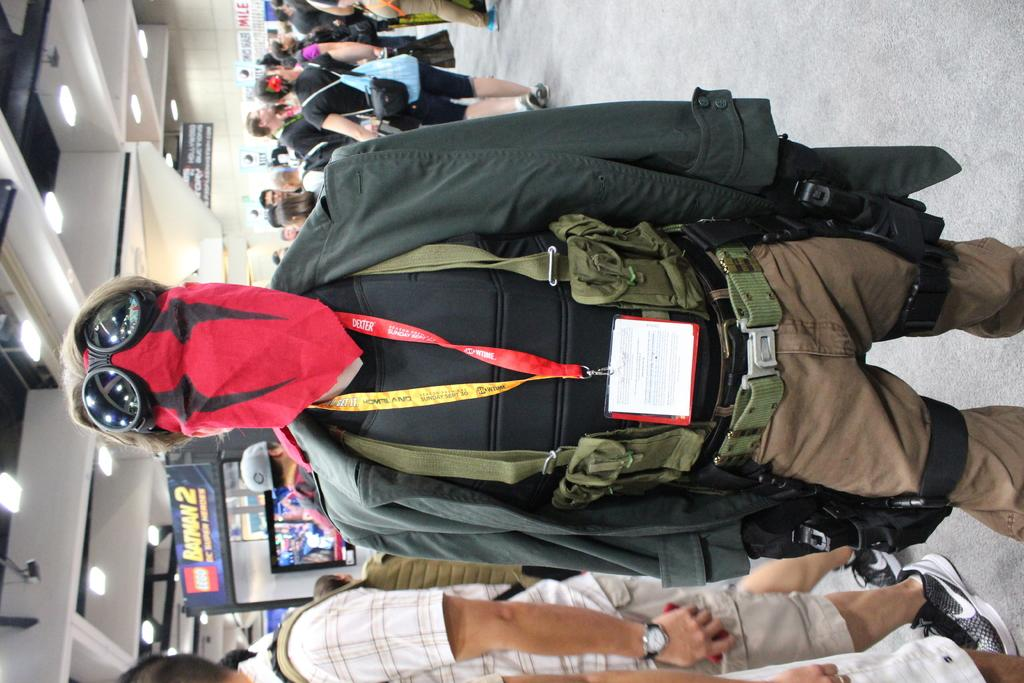<image>
Present a compact description of the photo's key features. A person in a costume in front of a Batman 2 DC Superheros stall. 